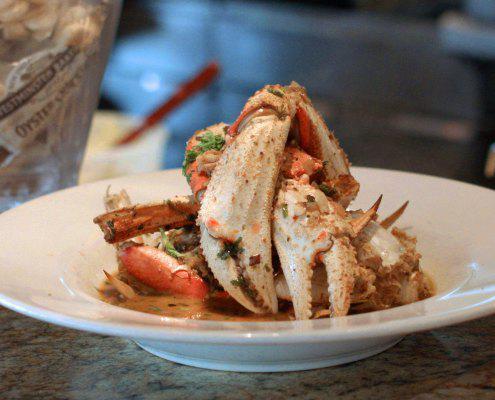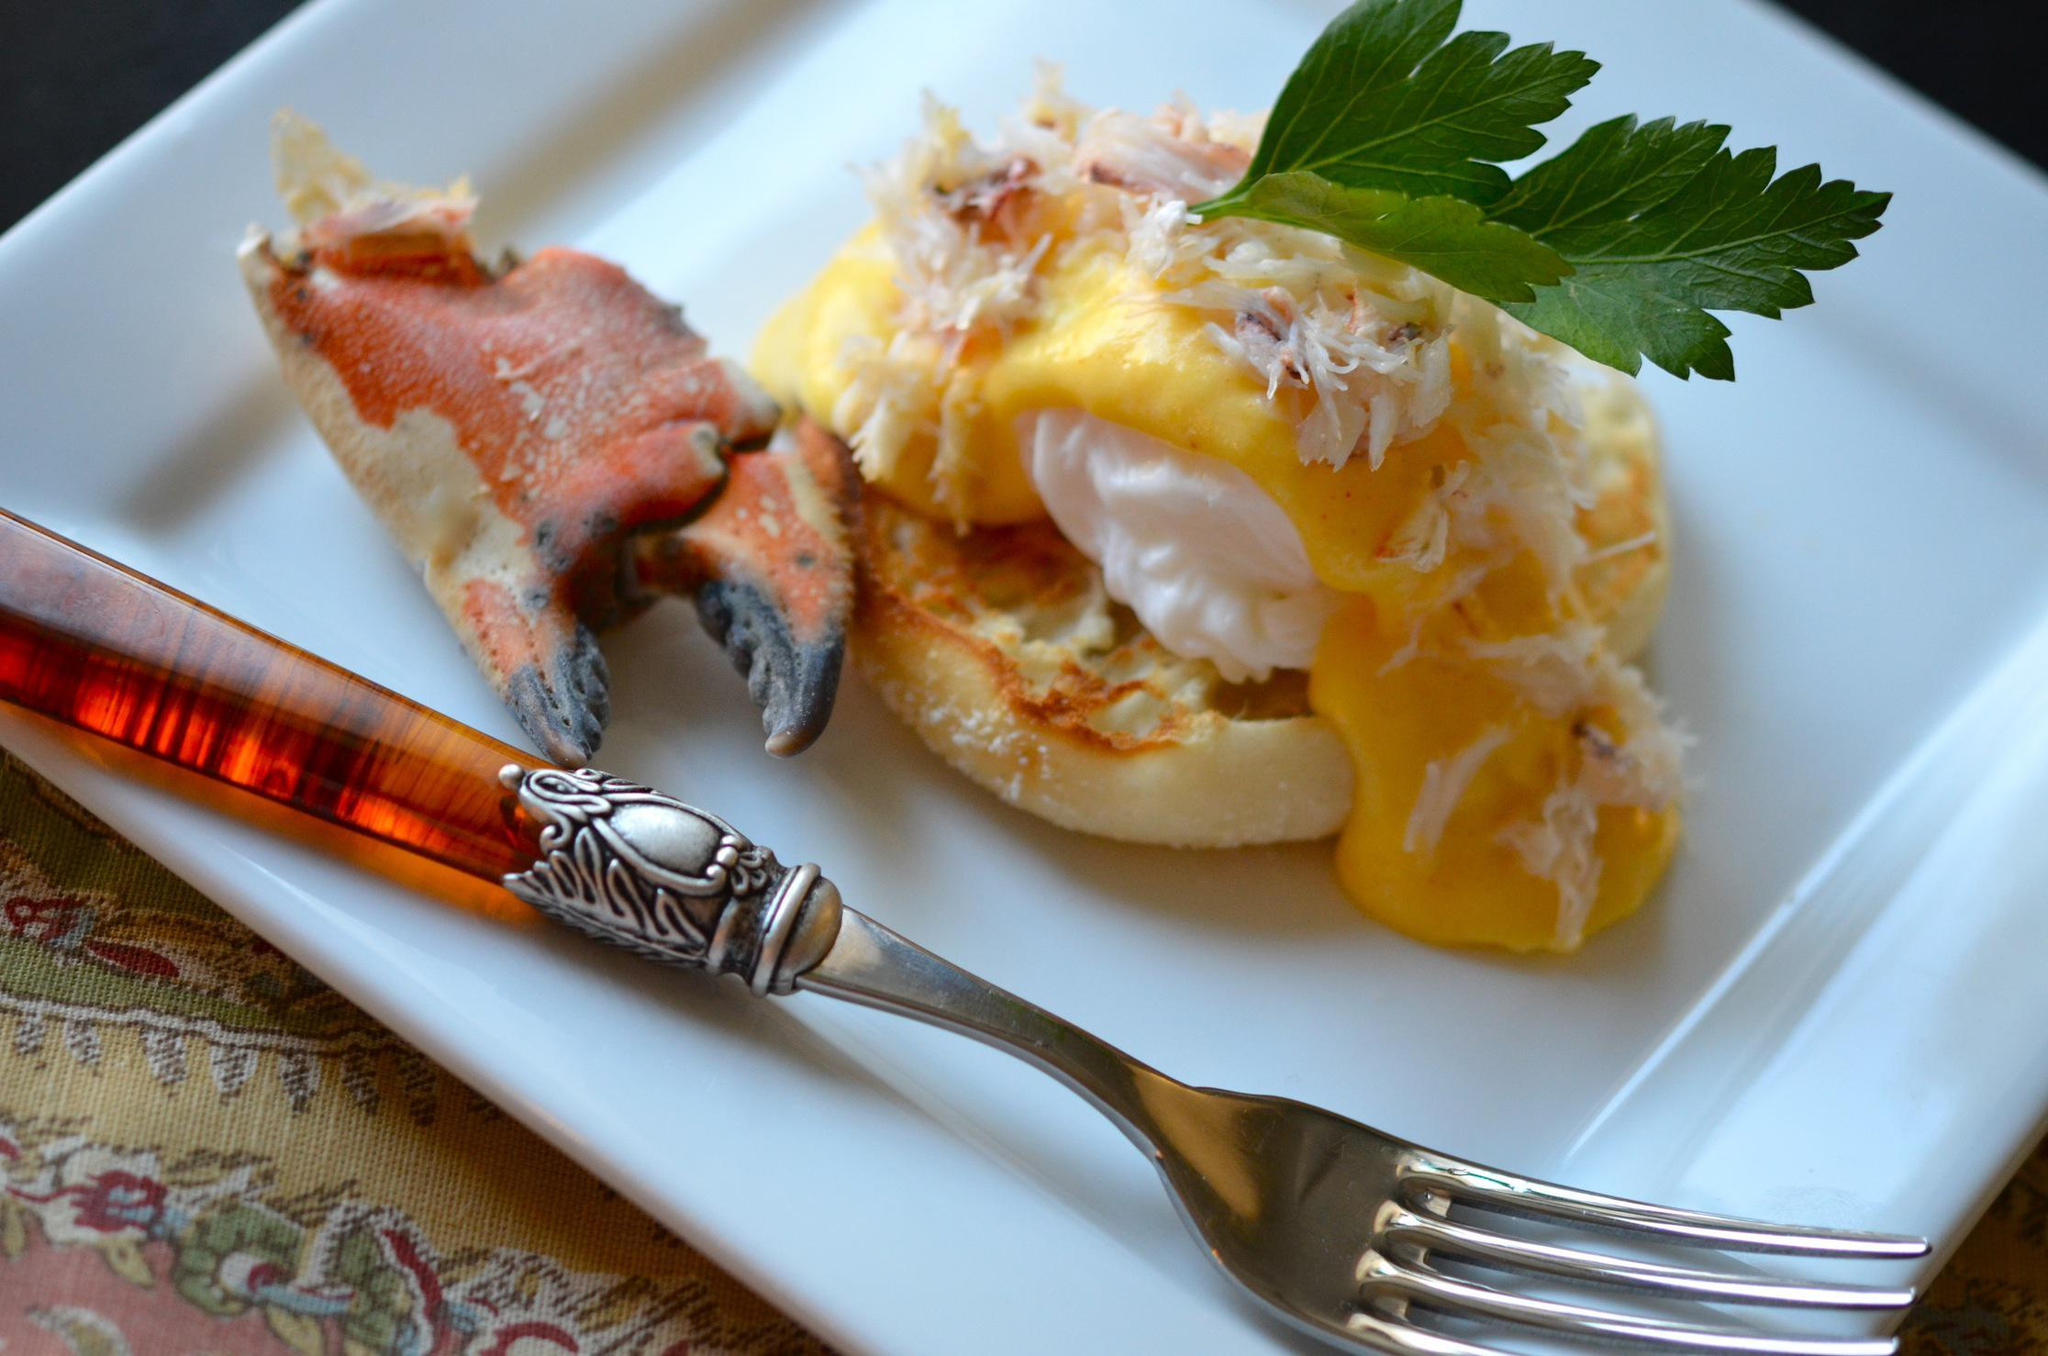The first image is the image on the left, the second image is the image on the right. Considering the images on both sides, is "One of the dishes is a whole crab." valid? Answer yes or no. No. 